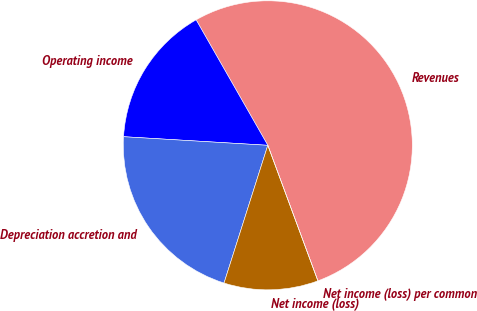Convert chart. <chart><loc_0><loc_0><loc_500><loc_500><pie_chart><fcel>Revenues<fcel>Operating income<fcel>Depreciation accretion and<fcel>Net income (loss)<fcel>Net income (loss) per common<nl><fcel>52.63%<fcel>15.79%<fcel>21.05%<fcel>10.53%<fcel>0.0%<nl></chart> 